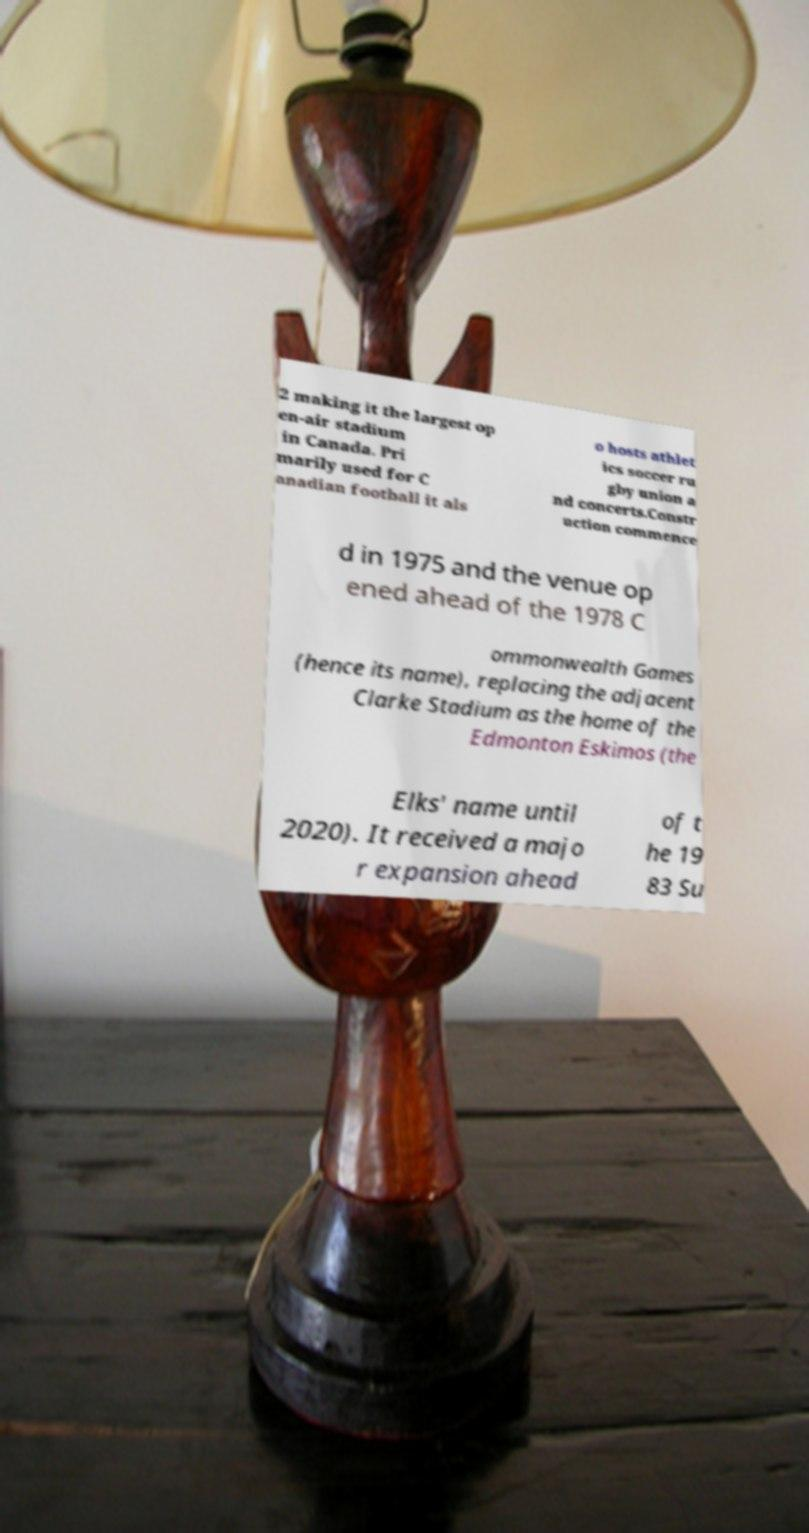Please identify and transcribe the text found in this image. 2 making it the largest op en-air stadium in Canada. Pri marily used for C anadian football it als o hosts athlet ics soccer ru gby union a nd concerts.Constr uction commence d in 1975 and the venue op ened ahead of the 1978 C ommonwealth Games (hence its name), replacing the adjacent Clarke Stadium as the home of the Edmonton Eskimos (the Elks' name until 2020). It received a majo r expansion ahead of t he 19 83 Su 